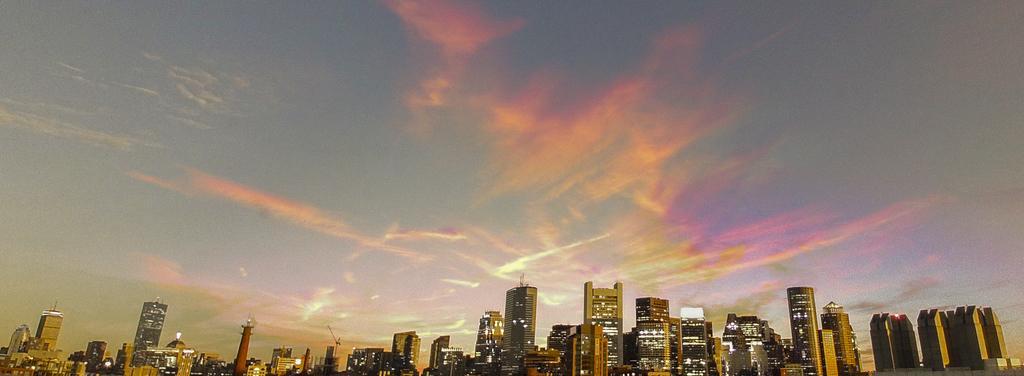Could you give a brief overview of what you see in this image? In the image we can see there so many buildings and we can see the lights. Here we can see the cloudy pale orange and pale blue sky. 